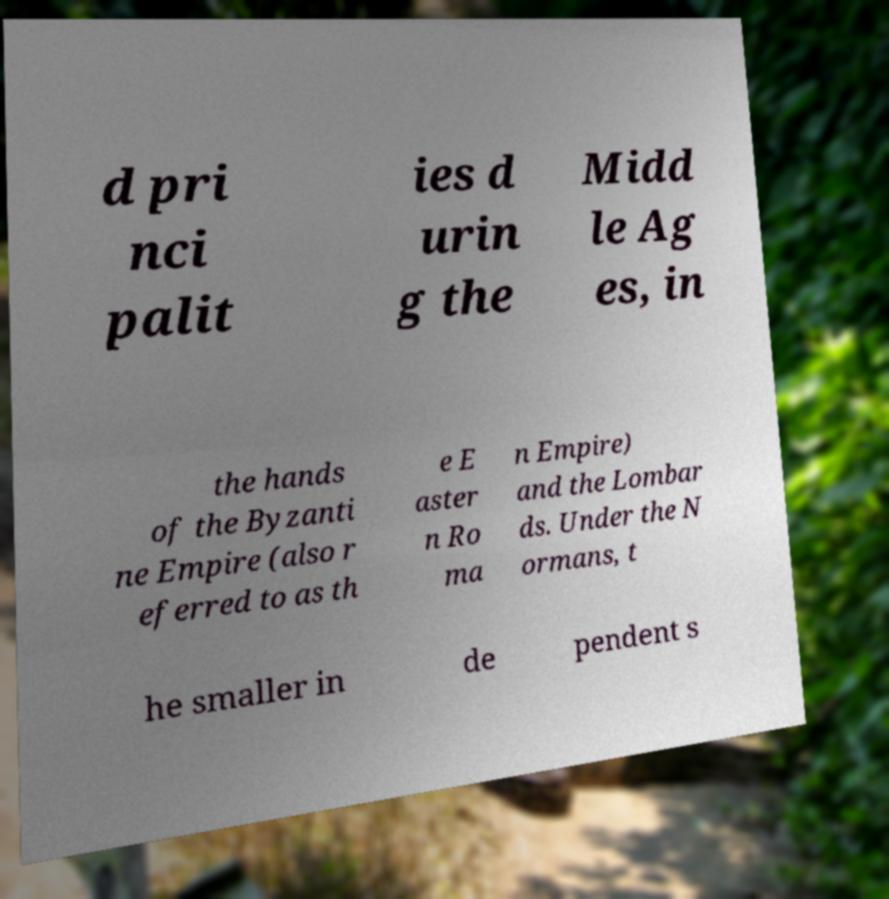Please identify and transcribe the text found in this image. d pri nci palit ies d urin g the Midd le Ag es, in the hands of the Byzanti ne Empire (also r eferred to as th e E aster n Ro ma n Empire) and the Lombar ds. Under the N ormans, t he smaller in de pendent s 